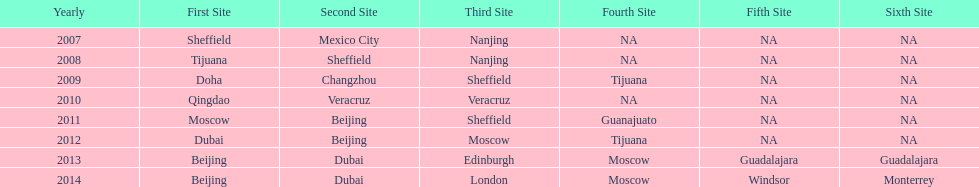For how many years has this world series been taking place? 7 years. 